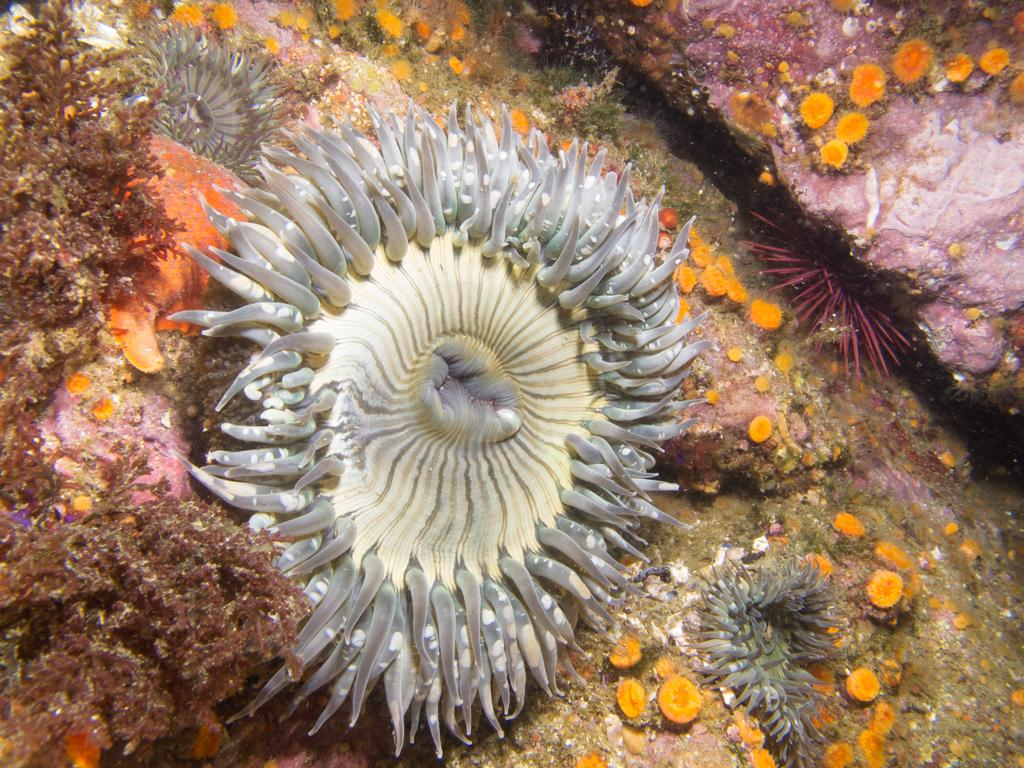What type of marine life can be seen in the image? The image contains sea anemones and coral reefs. What else can be seen in the image besides sea anemones and coral reefs? The image contains other aquatic objects. Where was the image taken? The image was taken in water. How many hooks are visible in the image? There are no hooks present in the image. 